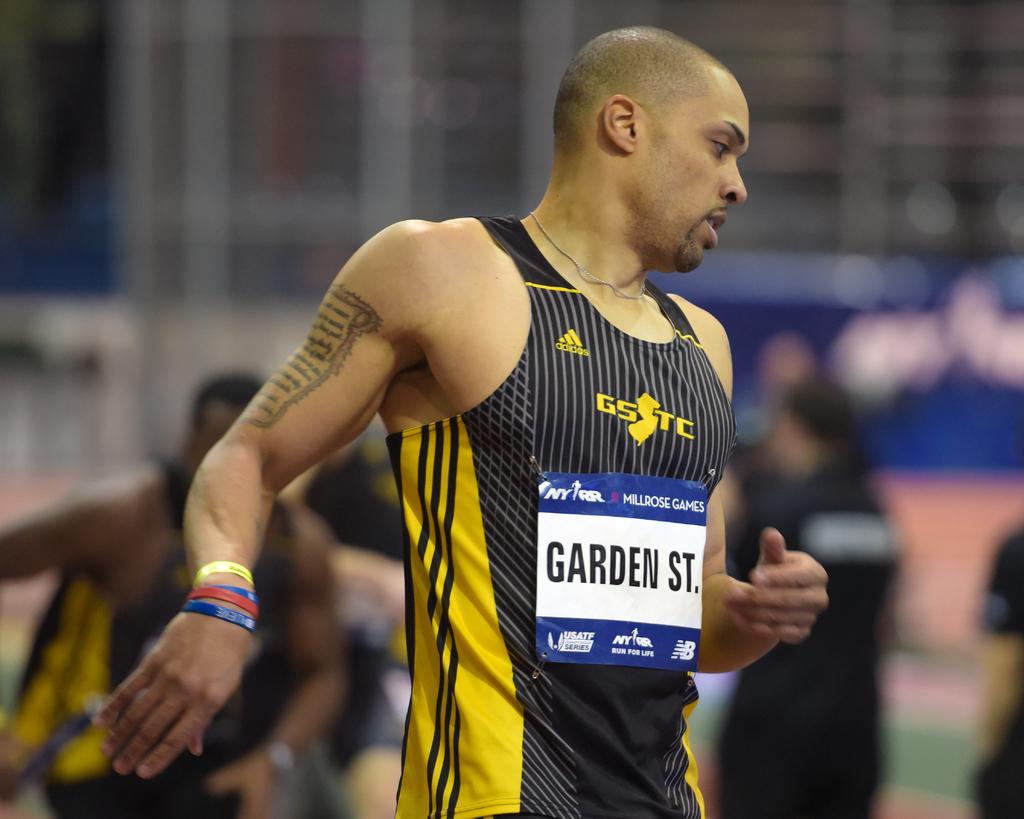Who does this runner represent?
Ensure brevity in your answer.  Garden st. What brand of shirt is the runner wearing?
Ensure brevity in your answer.  Adidas. 